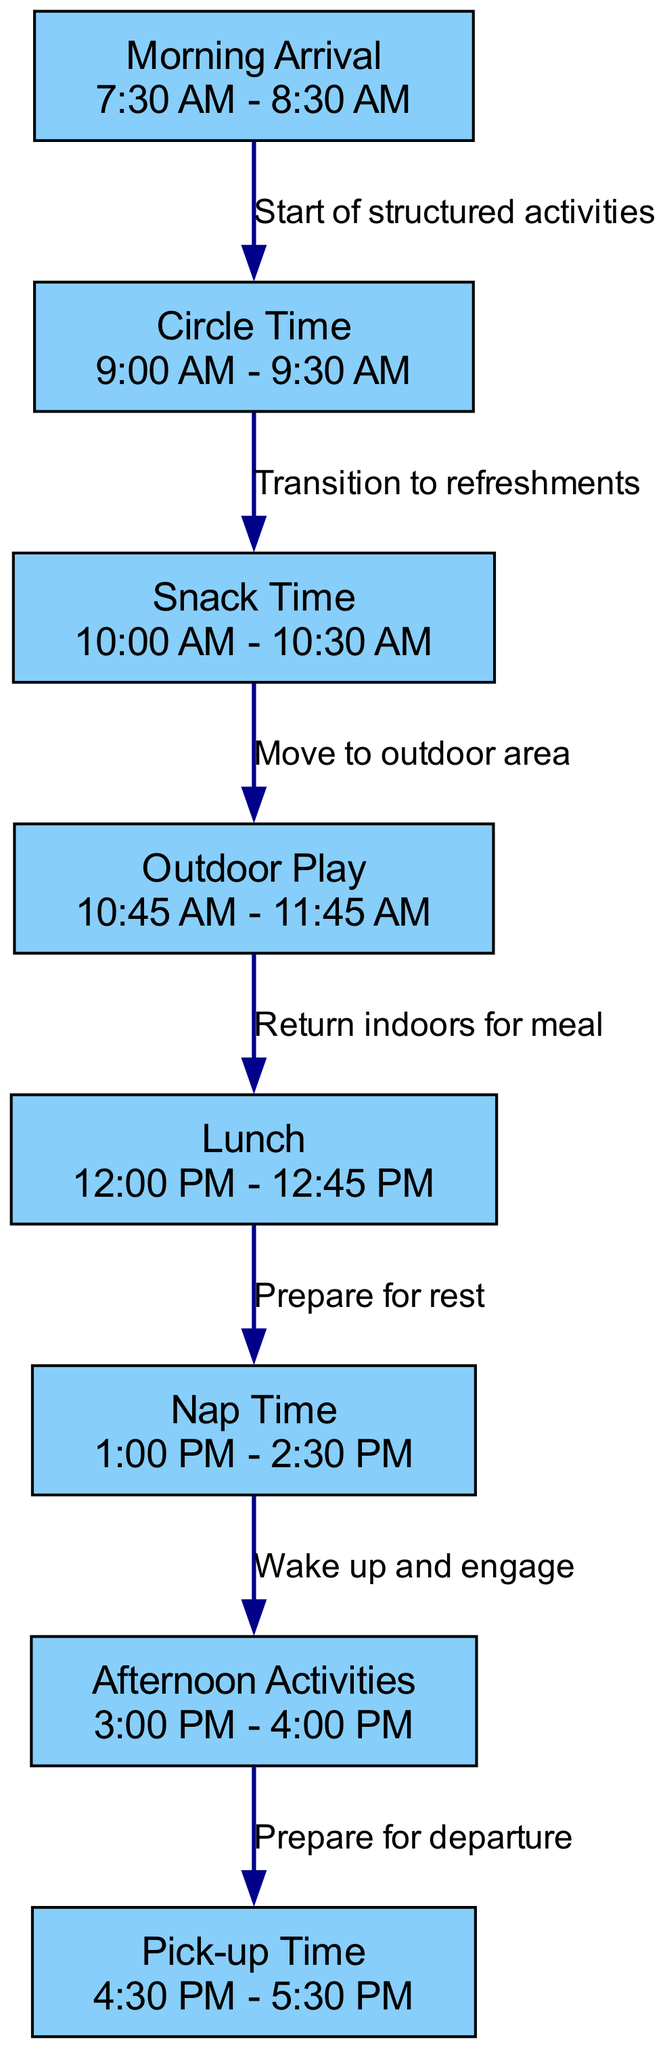What is the time for Snack Time? Snack Time is represented as a node in the diagram with the specific time mentioned underneath. By identifying the node labeled "Snack Time," we see that the corresponding time is "10:00 AM - 10:30 AM."
Answer: 10:00 AM - 10:30 AM How many nodes are present in the diagram? The nodes in the diagram represent different segments of the daily schedule. Counting the nodes listed in the data, we find a total of 8 nodes.
Answer: 8 What is the duration of Nap Time? Nap Time is indicated in the diagram, and reviewing the time block associated with it shows that it lasts from "1:00 PM" to "2:30 PM." The duration can be calculated as 1.5 hours or 90 minutes.
Answer: 90 minutes What comes right after Circle Time? Examining the edges that connect the nodes, we find that there is a direct transition from Circle Time to Snack Time. Therefore, Snack Time follows Circle Time.
Answer: Snack Time Which activity occurs just before Lunch? By tracing the diagram, we see that just before Lunch, the activity is Outdoor Play, indicated by an edge leading directly from Outdoor Play to Lunch.
Answer: Outdoor Play What is the purpose of the edge connecting Morning Arrival and Circle Time? The edge connecting Morning Arrival to Circle Time is labeled "Start of structured activities." This indicates that the structured activities begin after the arrival period.
Answer: Start of structured activities After Nap Time, which activity follows? Upon inspecting the nodes and edges, we find that the edge from Nap Time leads to Afternoon Activities, meaning that this is the next scheduled activity after Nap Time.
Answer: Afternoon Activities What time does Pick-up Time start? The node labeled "Pick-up Time" contains the time information listed beneath it. It states "4:30 PM - 5:30 PM" as the pick-up duration, indicating when parents can arrive to pick up their children.
Answer: 4:30 PM - 5:30 PM What is the transition labeled between Snack Time and Outdoor Play? The transition edge between Snack Time and Outdoor Play is labeled "Move to outdoor area." This denotes the movement from the snack period to the outdoor play session.
Answer: Move to outdoor area 